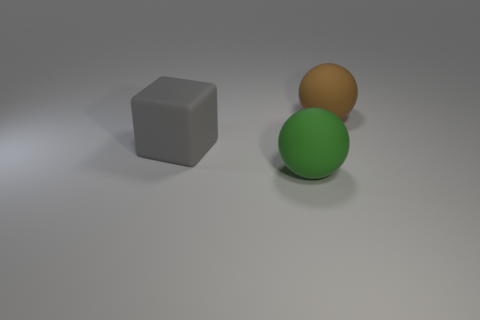Add 2 green balls. How many objects exist? 5 Subtract all spheres. How many objects are left? 1 Subtract all gray rubber cubes. Subtract all big green balls. How many objects are left? 1 Add 1 big brown things. How many big brown things are left? 2 Add 2 gray matte objects. How many gray matte objects exist? 3 Subtract 0 green cubes. How many objects are left? 3 